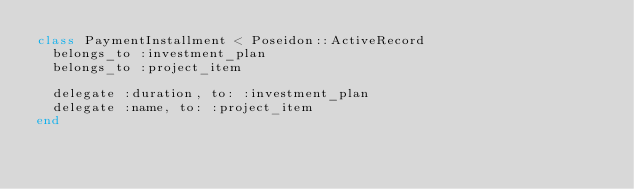Convert code to text. <code><loc_0><loc_0><loc_500><loc_500><_Ruby_>class PaymentInstallment < Poseidon::ActiveRecord
  belongs_to :investment_plan
  belongs_to :project_item

  delegate :duration, to: :investment_plan
  delegate :name, to: :project_item
end
</code> 